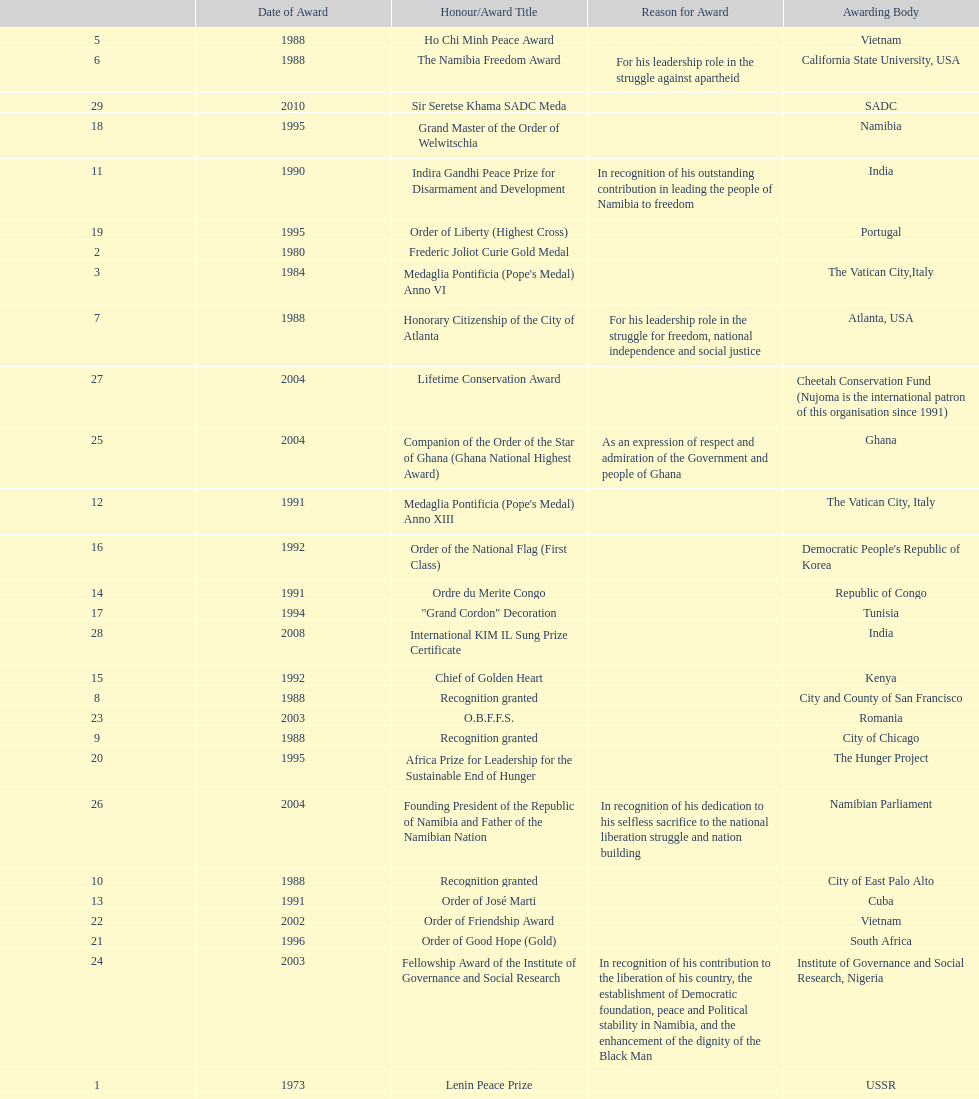What was the last award that nujoma won? Sir Seretse Khama SADC Meda. 